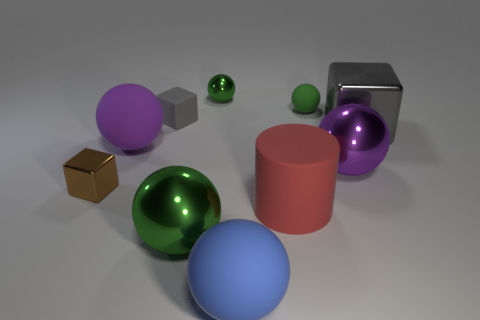Subtract all yellow blocks. How many green balls are left? 3 Subtract all purple balls. How many balls are left? 4 Subtract all purple spheres. How many spheres are left? 4 Subtract all blue spheres. Subtract all cyan blocks. How many spheres are left? 5 Subtract all cubes. How many objects are left? 7 Subtract 0 red balls. How many objects are left? 10 Subtract all green rubber things. Subtract all red cylinders. How many objects are left? 8 Add 5 rubber cylinders. How many rubber cylinders are left? 6 Add 2 large blue matte things. How many large blue matte things exist? 3 